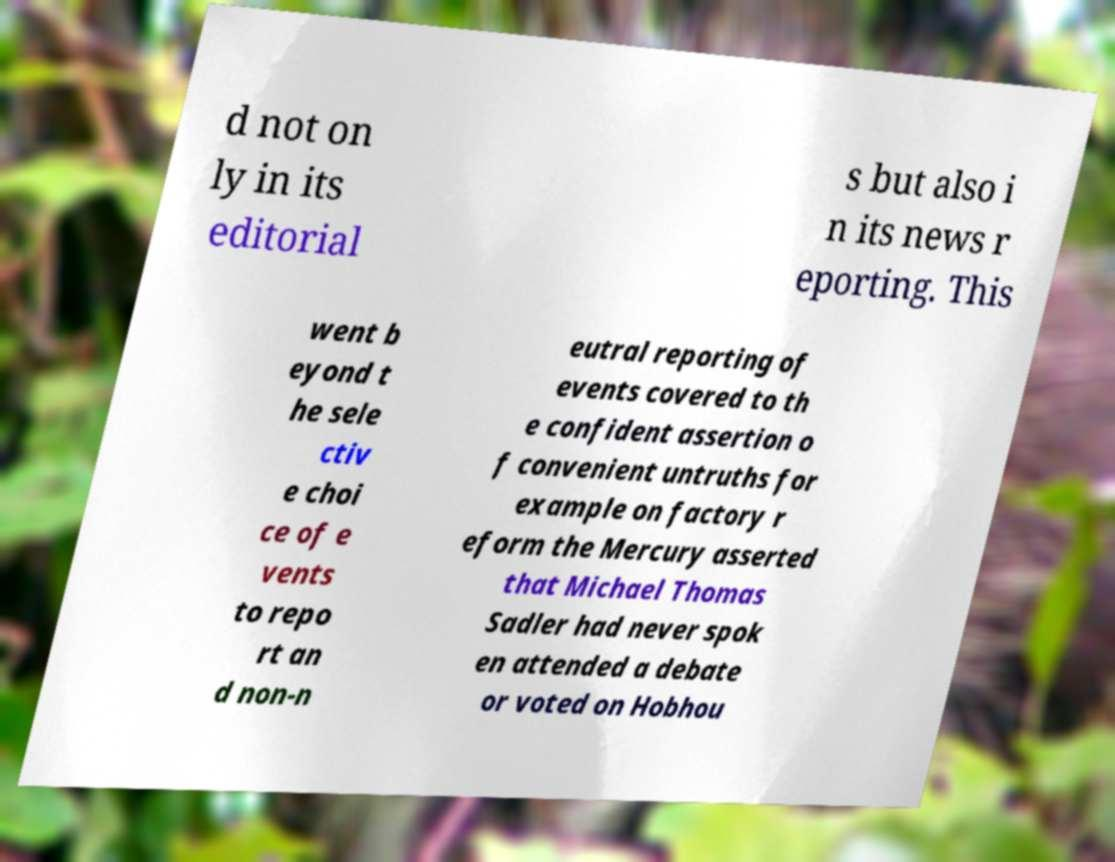Could you extract and type out the text from this image? d not on ly in its editorial s but also i n its news r eporting. This went b eyond t he sele ctiv e choi ce of e vents to repo rt an d non-n eutral reporting of events covered to th e confident assertion o f convenient untruths for example on factory r eform the Mercury asserted that Michael Thomas Sadler had never spok en attended a debate or voted on Hobhou 